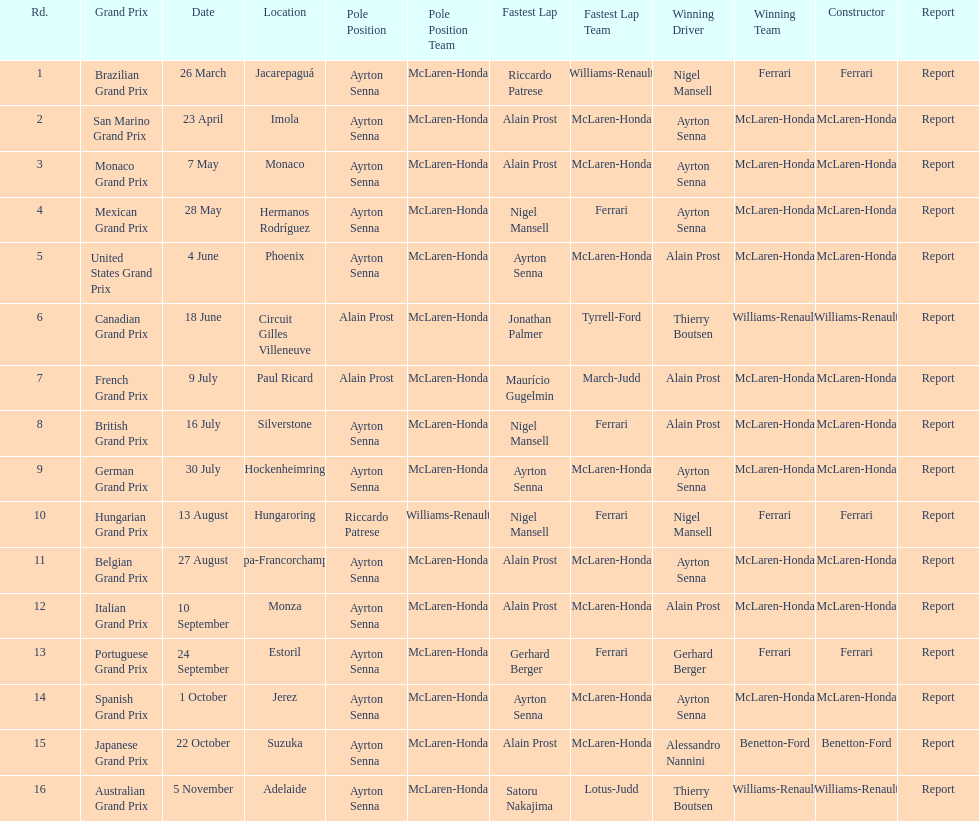Who had the fastest lap at the german grand prix? Ayrton Senna. 